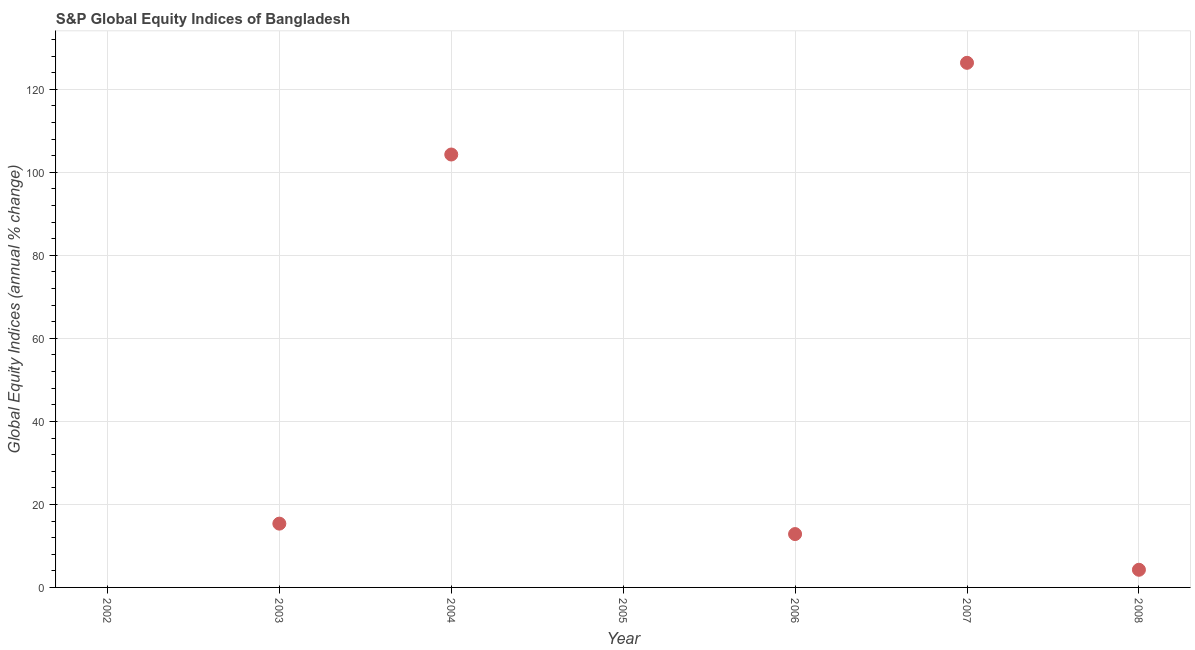What is the s&p global equity indices in 2004?
Your answer should be very brief. 104.3. Across all years, what is the maximum s&p global equity indices?
Your answer should be very brief. 126.39. What is the sum of the s&p global equity indices?
Provide a succinct answer. 263.17. What is the difference between the s&p global equity indices in 2004 and 2006?
Provide a succinct answer. 91.44. What is the average s&p global equity indices per year?
Give a very brief answer. 37.6. What is the median s&p global equity indices?
Provide a succinct answer. 12.86. In how many years, is the s&p global equity indices greater than 124 %?
Your response must be concise. 1. What is the ratio of the s&p global equity indices in 2003 to that in 2008?
Offer a very short reply. 3.61. Is the s&p global equity indices in 2003 less than that in 2007?
Keep it short and to the point. Yes. What is the difference between the highest and the second highest s&p global equity indices?
Provide a succinct answer. 22.09. What is the difference between the highest and the lowest s&p global equity indices?
Provide a succinct answer. 126.39. In how many years, is the s&p global equity indices greater than the average s&p global equity indices taken over all years?
Offer a very short reply. 2. Does the s&p global equity indices monotonically increase over the years?
Make the answer very short. No. How many dotlines are there?
Your response must be concise. 1. How many years are there in the graph?
Give a very brief answer. 7. Are the values on the major ticks of Y-axis written in scientific E-notation?
Offer a very short reply. No. What is the title of the graph?
Provide a succinct answer. S&P Global Equity Indices of Bangladesh. What is the label or title of the Y-axis?
Ensure brevity in your answer.  Global Equity Indices (annual % change). What is the Global Equity Indices (annual % change) in 2002?
Your response must be concise. 0. What is the Global Equity Indices (annual % change) in 2003?
Your answer should be very brief. 15.37. What is the Global Equity Indices (annual % change) in 2004?
Ensure brevity in your answer.  104.3. What is the Global Equity Indices (annual % change) in 2005?
Offer a very short reply. 0. What is the Global Equity Indices (annual % change) in 2006?
Provide a succinct answer. 12.86. What is the Global Equity Indices (annual % change) in 2007?
Ensure brevity in your answer.  126.39. What is the Global Equity Indices (annual % change) in 2008?
Your answer should be very brief. 4.25. What is the difference between the Global Equity Indices (annual % change) in 2003 and 2004?
Make the answer very short. -88.93. What is the difference between the Global Equity Indices (annual % change) in 2003 and 2006?
Your answer should be very brief. 2.51. What is the difference between the Global Equity Indices (annual % change) in 2003 and 2007?
Offer a terse response. -111.02. What is the difference between the Global Equity Indices (annual % change) in 2003 and 2008?
Provide a succinct answer. 11.12. What is the difference between the Global Equity Indices (annual % change) in 2004 and 2006?
Give a very brief answer. 91.44. What is the difference between the Global Equity Indices (annual % change) in 2004 and 2007?
Ensure brevity in your answer.  -22.09. What is the difference between the Global Equity Indices (annual % change) in 2004 and 2008?
Keep it short and to the point. 100.05. What is the difference between the Global Equity Indices (annual % change) in 2006 and 2007?
Give a very brief answer. -113.54. What is the difference between the Global Equity Indices (annual % change) in 2006 and 2008?
Keep it short and to the point. 8.6. What is the difference between the Global Equity Indices (annual % change) in 2007 and 2008?
Give a very brief answer. 122.14. What is the ratio of the Global Equity Indices (annual % change) in 2003 to that in 2004?
Your response must be concise. 0.15. What is the ratio of the Global Equity Indices (annual % change) in 2003 to that in 2006?
Your response must be concise. 1.2. What is the ratio of the Global Equity Indices (annual % change) in 2003 to that in 2007?
Ensure brevity in your answer.  0.12. What is the ratio of the Global Equity Indices (annual % change) in 2003 to that in 2008?
Give a very brief answer. 3.61. What is the ratio of the Global Equity Indices (annual % change) in 2004 to that in 2006?
Offer a very short reply. 8.11. What is the ratio of the Global Equity Indices (annual % change) in 2004 to that in 2007?
Offer a very short reply. 0.82. What is the ratio of the Global Equity Indices (annual % change) in 2004 to that in 2008?
Keep it short and to the point. 24.52. What is the ratio of the Global Equity Indices (annual % change) in 2006 to that in 2007?
Provide a short and direct response. 0.1. What is the ratio of the Global Equity Indices (annual % change) in 2006 to that in 2008?
Provide a succinct answer. 3.02. What is the ratio of the Global Equity Indices (annual % change) in 2007 to that in 2008?
Your answer should be very brief. 29.71. 